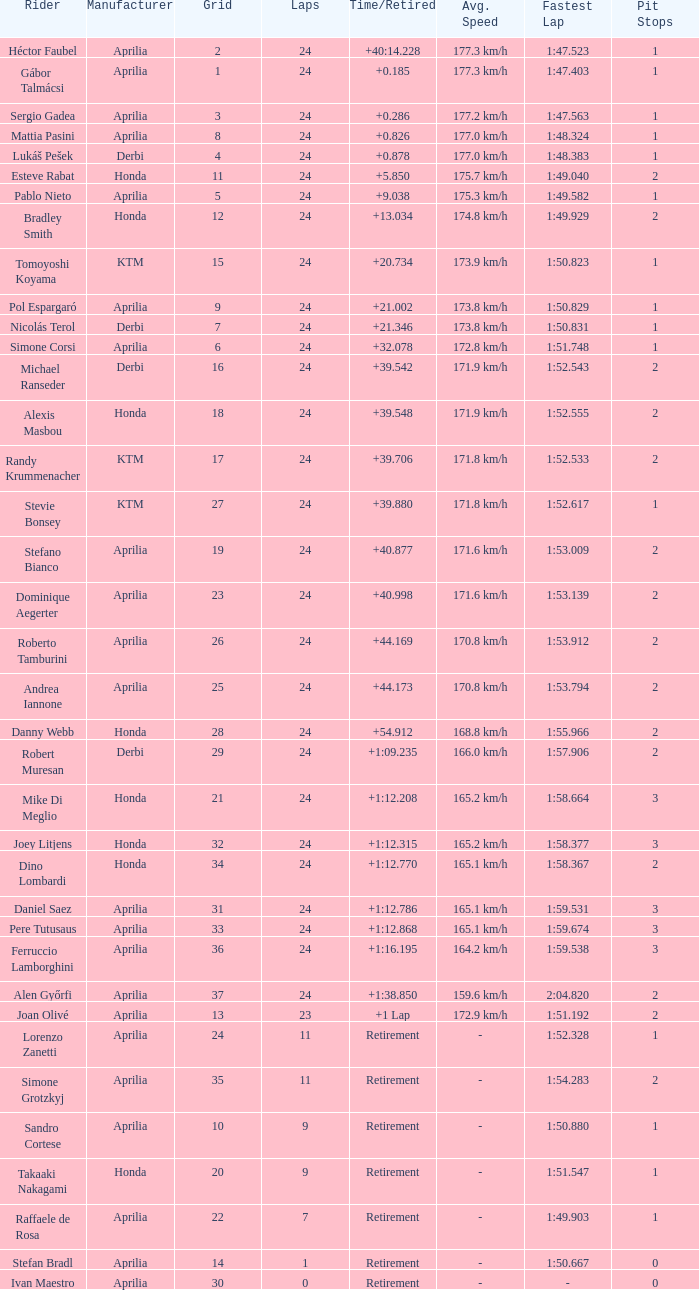What is the time with 10 grids? Retirement. 